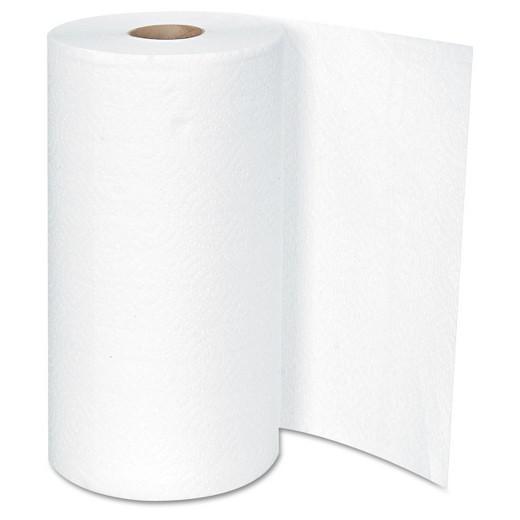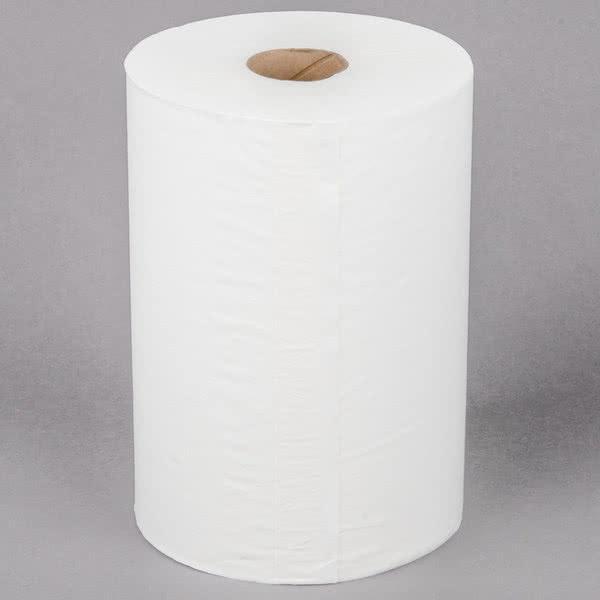The first image is the image on the left, the second image is the image on the right. Considering the images on both sides, is "Only one of the paper towel rolls is on the paper towel holder." valid? Answer yes or no. No. The first image is the image on the left, the second image is the image on the right. Given the left and right images, does the statement "One image shows a towel roll without a stand and without any sheet unfurled." hold true? Answer yes or no. Yes. 